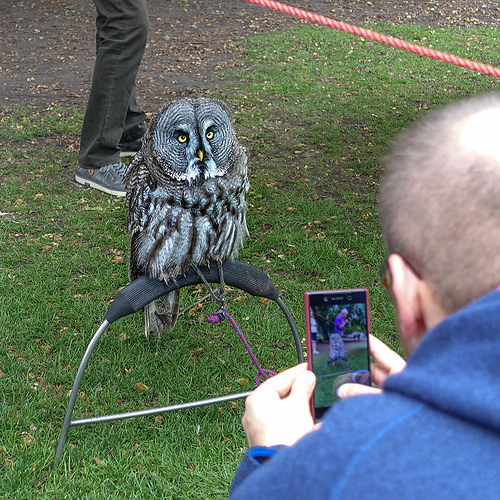<image>
Is the owl in the phone? Yes. The owl is contained within or inside the phone, showing a containment relationship. Is the owl in front of the man? Yes. The owl is positioned in front of the man, appearing closer to the camera viewpoint. 